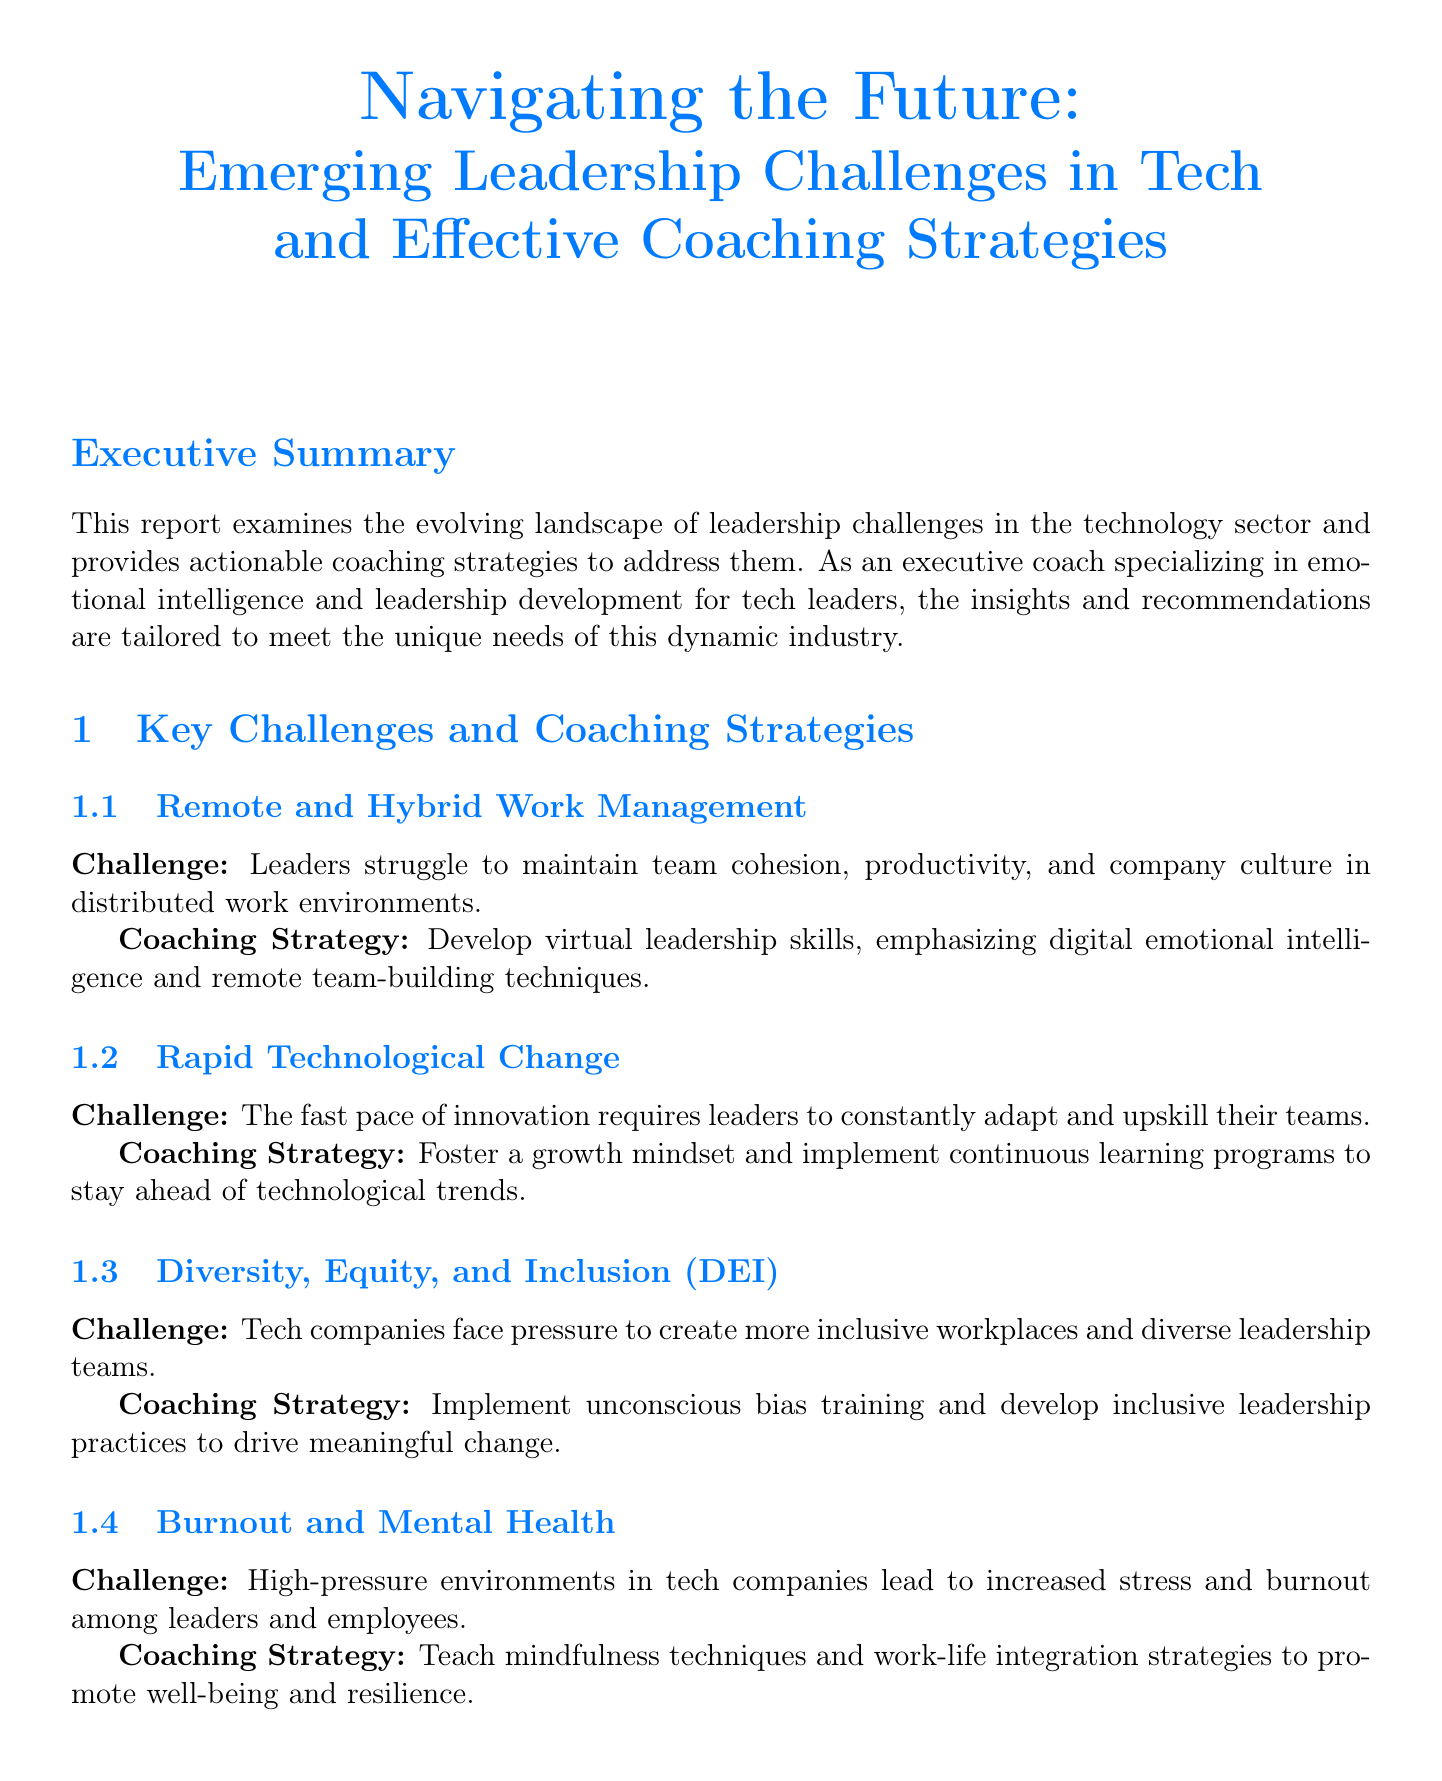what is the title of the report? The title of the report is mentioned in the document header.
Answer: Navigating the Future: Emerging Leadership Challenges in Tech and Effective Coaching Strategies how many participants were in the TechLeaders Annual Survey 2023? The number of participants is stated in the industry data section of the document.
Answer: 1500 what percentage of tech leaders report difficulty in maintaining team engagement in remote settings? This percentage is found in the key findings of the industry data section.
Answer: 78% what coaching strategy is recommended for managing remote and hybrid work? The coaching strategy for remote work management is outlined in the key challenges section.
Answer: Develop virtual leadership skills which case study highlights improving diversity in leadership positions? This case study is explicitly presented in the case studies section.
Answer: Microsoft how many key challenges are discussed in the report? The total number of key challenges is counted in the document's key challenges section.
Answer: Four what is the name of the coaching framework provided in the report? The name is specified in the coaching framework section of the document.
Answer: LEAD: Listen, Empathize, Adapt, Develop what is the outcome of Salesforce's virtual leadership training program? The outcome is stated in the case study about Salesforce.
Answer: Increased employee satisfaction by 22% and maintained productivity levels what is one of the emerging trends mentioned for future leadership in tech? The emerging trends are listed under the future outlook section.
Answer: AI-augmented leadership decision-making 